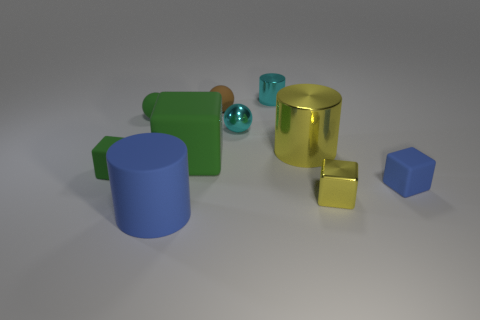There is a green thing that is the same shape as the brown matte thing; what is it made of?
Offer a terse response. Rubber. How many purple things are big rubber objects or tiny cylinders?
Your answer should be very brief. 0. Is there anything else that has the same color as the metal sphere?
Your response must be concise. Yes. There is a big matte object in front of the tiny green object in front of the large yellow metal cylinder; what color is it?
Provide a short and direct response. Blue. Is the number of small green matte blocks to the right of the cyan cylinder less than the number of big rubber objects behind the tiny green ball?
Your answer should be very brief. No. There is a block that is the same color as the big metal object; what material is it?
Give a very brief answer. Metal. What number of objects are rubber things to the left of the yellow shiny cube or large green rubber cubes?
Provide a short and direct response. 5. There is a blue object that is left of the brown sphere; is it the same size as the small shiny ball?
Your response must be concise. No. Are there fewer brown things that are right of the small metallic cylinder than tiny yellow shiny cylinders?
Make the answer very short. No. There is another cylinder that is the same size as the yellow metallic cylinder; what is it made of?
Your response must be concise. Rubber. 